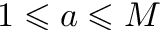Convert formula to latex. <formula><loc_0><loc_0><loc_500><loc_500>1 \leqslant a \leqslant M</formula> 